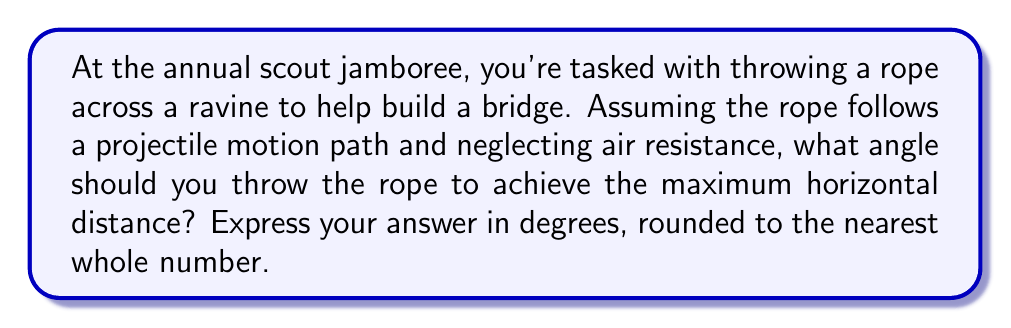Help me with this question. Let's approach this step-by-step:

1) In projectile motion, the horizontal distance $d$ traveled by an object thrown with initial velocity $v_0$ at an angle $\theta$ to the horizontal is given by:

   $$d = \frac{v_0^2 \sin(2\theta)}{g}$$

   where $g$ is the acceleration due to gravity.

2) To find the maximum distance, we need to maximize $\sin(2\theta)$. 

3) The sine function reaches its maximum value of 1 when its argument is 90°.

4) So, we want:

   $$2\theta = 90°$$

5) Solving for $\theta$:

   $$\theta = 45°$$

6) This result is independent of the initial velocity and the acceleration due to gravity, making it universally applicable for projectile motion problems (neglecting air resistance).

7) Rounding to the nearest whole number isn't necessary in this case as 45° is already a whole number.
Answer: 45° 